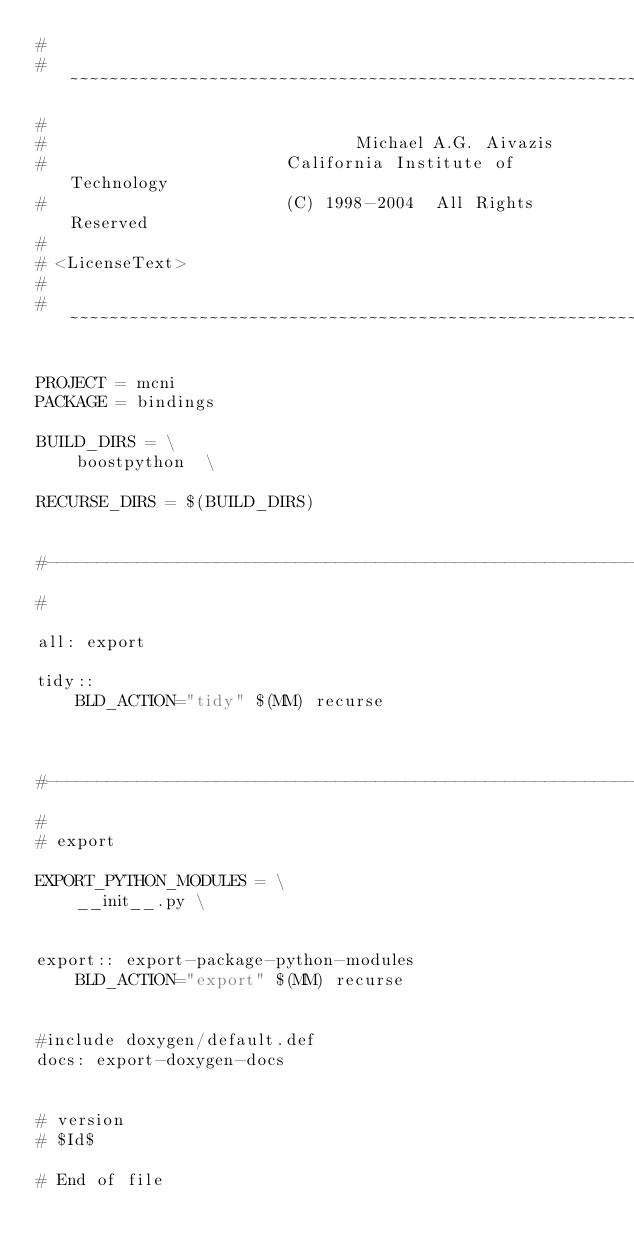<code> <loc_0><loc_0><loc_500><loc_500><_ObjectiveC_>#
# ~~~~~~~~~~~~~~~~~~~~~~~~~~~~~~~~~~~~~~~~~~~~~~~~~~~~~~~~~~~~~~~~~~~~~~~~~~~~~~~~
#
#                               Michael A.G. Aivazis
#                        California Institute of Technology
#                        (C) 1998-2004  All Rights Reserved
#
# <LicenseText>
#
# ~~~~~~~~~~~~~~~~~~~~~~~~~~~~~~~~~~~~~~~~~~~~~~~~~~~~~~~~~~~~~~~~~~~~~~~~~~~~~~~~

PROJECT = mcni
PACKAGE = bindings

BUILD_DIRS = \
    boostpython  \

RECURSE_DIRS = $(BUILD_DIRS)


#--------------------------------------------------------------------------
#

all: export

tidy::
	BLD_ACTION="tidy" $(MM) recurse



#--------------------------------------------------------------------------
#
# export

EXPORT_PYTHON_MODULES = \
	__init__.py \


export:: export-package-python-modules 
	BLD_ACTION="export" $(MM) recurse


#include doxygen/default.def
docs: export-doxygen-docs


# version
# $Id$

# End of file
</code> 